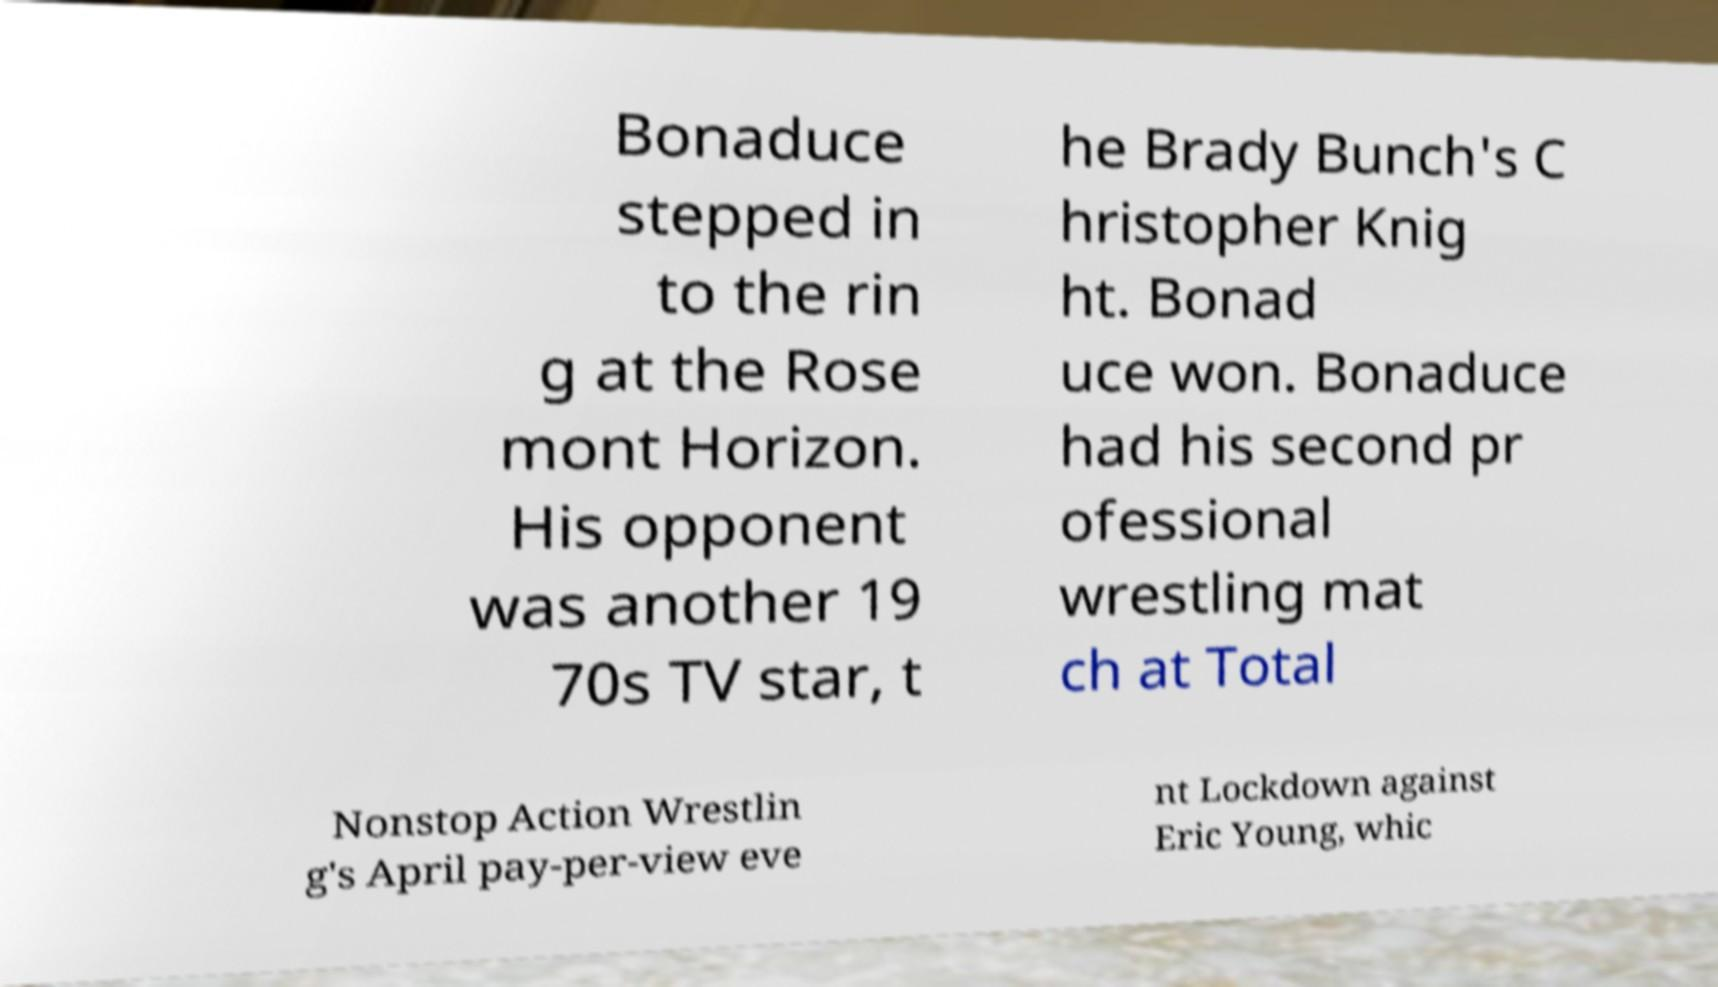Please identify and transcribe the text found in this image. Bonaduce stepped in to the rin g at the Rose mont Horizon. His opponent was another 19 70s TV star, t he Brady Bunch's C hristopher Knig ht. Bonad uce won. Bonaduce had his second pr ofessional wrestling mat ch at Total Nonstop Action Wrestlin g's April pay-per-view eve nt Lockdown against Eric Young, whic 